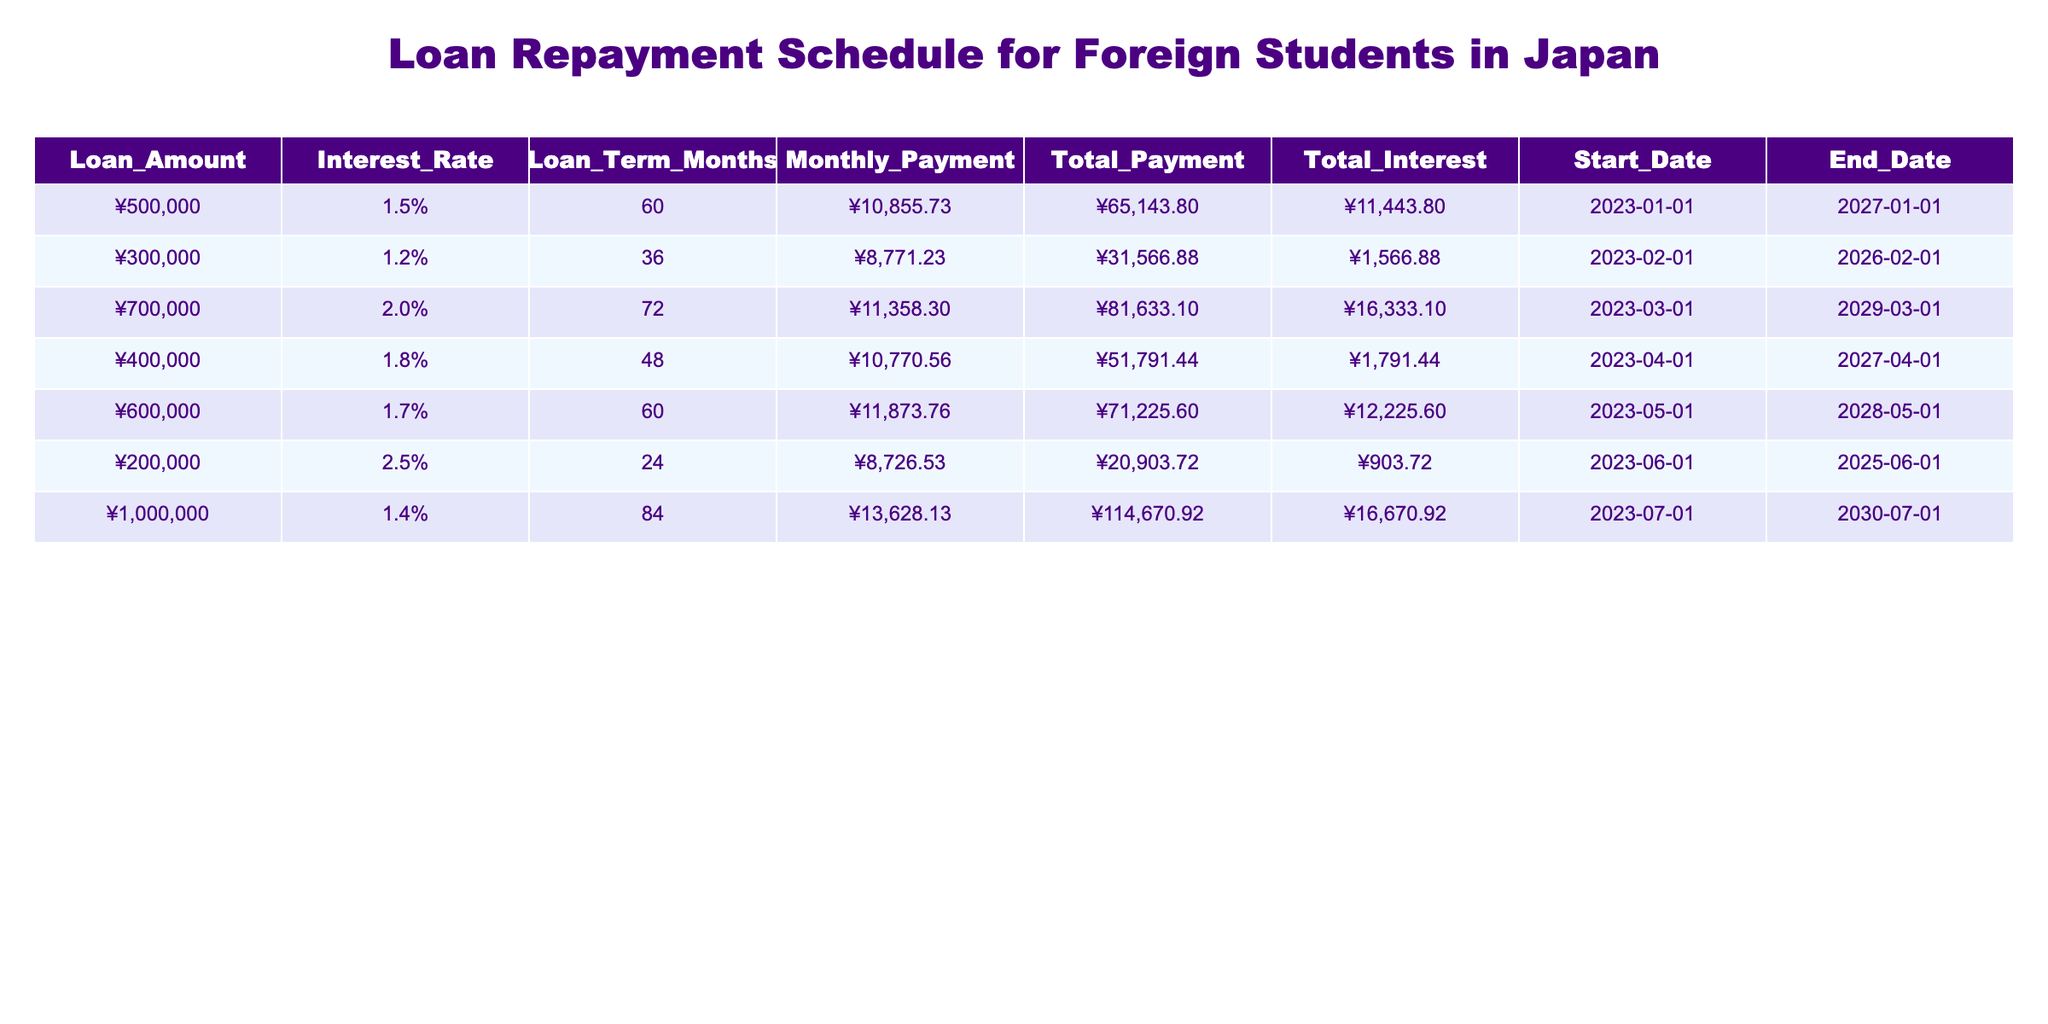What is the loan amount for the highest interest rate? The highest interest rate in the table is 2.5%, which is associated with a loan of ¥200,000.
Answer: ¥200,000 What is the total interest paid for a loan amount of ¥600,000? The total interest for the loan amount of ¥600,000 with an interest rate of 1.7% is ¥12,225.60 as seen in the corresponding row.
Answer: ¥12,225.60 How many loans have a loan term of 60 months or more? There are three loans with terms of 60 months or more: ¥500,000 for 60 months, ¥700,000 for 72 months, and ¥1,000,000 for 84 months. This gives a total of 3 loans.
Answer: 3 Which loan has the lowest monthly payment? The loan with the lowest monthly payment is the ¥200,000 loan with a monthly payment of ¥8,726.53, noted in its row.
Answer: ¥8,726.53 What is the average total payment across all loans? The total payments for all loans are summed up: (65,143.80 + 31,566.88 + 81,633.10 + 51,791.44 + 71,225.60 + 20,903.72 + 114,670.92) = 434,406.56. There are 7 total loans, so the average is 434,406.56 / 7 = 62,057.65.
Answer: ¥62,057.65 Is there a loan that ends on the same date as it starts? No, all loans in the table have different start and end dates, meaning none have the same date for start and end.
Answer: No Which loan has the highest total payment? The loan with the highest total payment is the ¥1,000,000 loan, which has a total payment of ¥114,670.92 as seen in its row.
Answer: ¥114,670.92 What is the total interest paid by the loan with a term of 36 months? The total interest paid for the loan with a term of 36 months (¥300,000 with an interest rate of 1.2%) is ¥1,566.88 as listed in the table.
Answer: ¥1,566.88 What is the difference in total payment between the loan for ¥700,000 and the loan for ¥200,000? The total payment for the ¥700,000 loan is ¥81,633.10 and the total payment for the ¥200,000 loan is ¥20,903.72. The difference is 81,633.10 - 20,903.72 = 60,729.38.
Answer: ¥60,729.38 